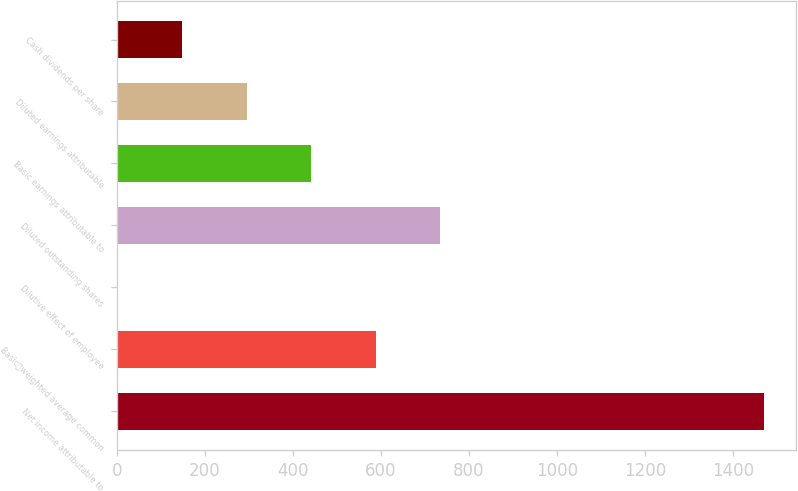Convert chart to OTSL. <chart><loc_0><loc_0><loc_500><loc_500><bar_chart><fcel>Net income attributable to<fcel>Basicweighted average common<fcel>Dilutive effect of employee<fcel>Diluted outstanding shares<fcel>Basic earnings attributable to<fcel>Diluted earnings attributable<fcel>Cash dividends per share<nl><fcel>1469<fcel>588.2<fcel>1<fcel>735<fcel>441.4<fcel>294.6<fcel>147.8<nl></chart> 